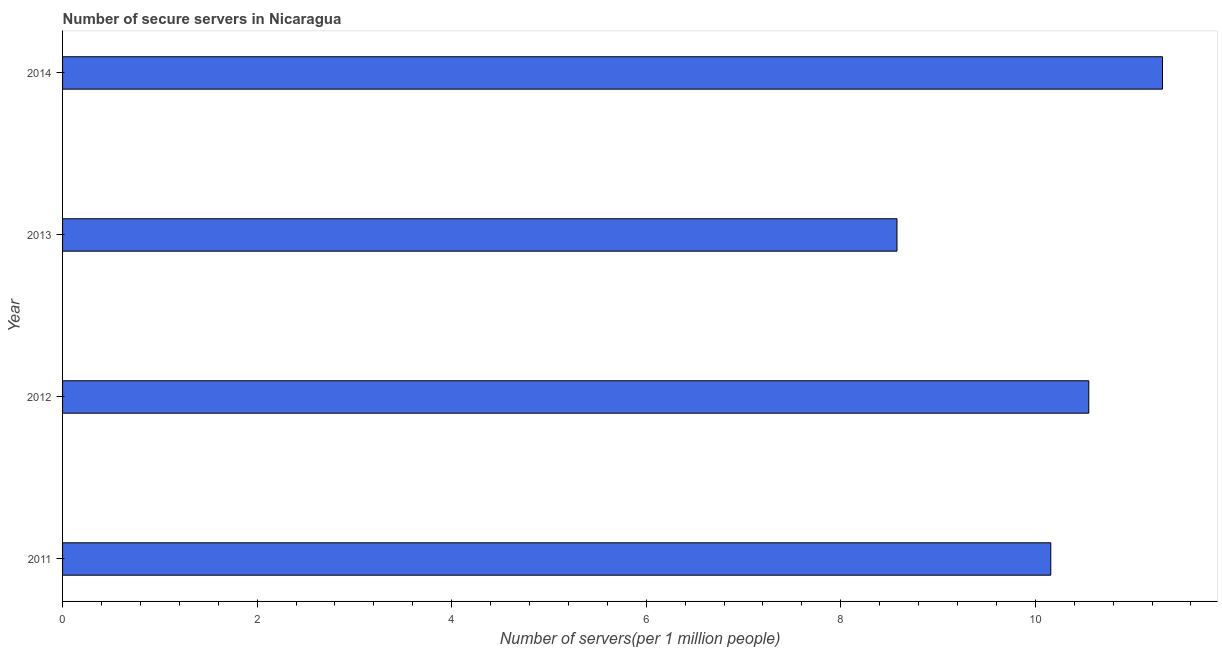Does the graph contain any zero values?
Your answer should be compact. No. What is the title of the graph?
Your response must be concise. Number of secure servers in Nicaragua. What is the label or title of the X-axis?
Your answer should be compact. Number of servers(per 1 million people). What is the label or title of the Y-axis?
Your answer should be very brief. Year. What is the number of secure internet servers in 2012?
Your response must be concise. 10.55. Across all years, what is the maximum number of secure internet servers?
Offer a very short reply. 11.31. Across all years, what is the minimum number of secure internet servers?
Ensure brevity in your answer.  8.58. What is the sum of the number of secure internet servers?
Make the answer very short. 40.59. What is the difference between the number of secure internet servers in 2011 and 2013?
Provide a short and direct response. 1.58. What is the average number of secure internet servers per year?
Your answer should be very brief. 10.15. What is the median number of secure internet servers?
Make the answer very short. 10.35. In how many years, is the number of secure internet servers greater than 8.8 ?
Keep it short and to the point. 3. Do a majority of the years between 2011 and 2012 (inclusive) have number of secure internet servers greater than 2.4 ?
Your response must be concise. Yes. Is the number of secure internet servers in 2013 less than that in 2014?
Give a very brief answer. Yes. What is the difference between the highest and the second highest number of secure internet servers?
Give a very brief answer. 0.76. Is the sum of the number of secure internet servers in 2013 and 2014 greater than the maximum number of secure internet servers across all years?
Give a very brief answer. Yes. What is the difference between the highest and the lowest number of secure internet servers?
Provide a succinct answer. 2.73. How many bars are there?
Offer a very short reply. 4. Are all the bars in the graph horizontal?
Keep it short and to the point. Yes. Are the values on the major ticks of X-axis written in scientific E-notation?
Ensure brevity in your answer.  No. What is the Number of servers(per 1 million people) of 2011?
Your answer should be compact. 10.16. What is the Number of servers(per 1 million people) of 2012?
Your answer should be very brief. 10.55. What is the Number of servers(per 1 million people) of 2013?
Offer a very short reply. 8.58. What is the Number of servers(per 1 million people) of 2014?
Keep it short and to the point. 11.31. What is the difference between the Number of servers(per 1 million people) in 2011 and 2012?
Offer a terse response. -0.39. What is the difference between the Number of servers(per 1 million people) in 2011 and 2013?
Offer a terse response. 1.58. What is the difference between the Number of servers(per 1 million people) in 2011 and 2014?
Your answer should be compact. -1.15. What is the difference between the Number of servers(per 1 million people) in 2012 and 2013?
Ensure brevity in your answer.  1.97. What is the difference between the Number of servers(per 1 million people) in 2012 and 2014?
Give a very brief answer. -0.76. What is the difference between the Number of servers(per 1 million people) in 2013 and 2014?
Offer a very short reply. -2.73. What is the ratio of the Number of servers(per 1 million people) in 2011 to that in 2012?
Offer a terse response. 0.96. What is the ratio of the Number of servers(per 1 million people) in 2011 to that in 2013?
Offer a very short reply. 1.18. What is the ratio of the Number of servers(per 1 million people) in 2011 to that in 2014?
Offer a terse response. 0.9. What is the ratio of the Number of servers(per 1 million people) in 2012 to that in 2013?
Provide a short and direct response. 1.23. What is the ratio of the Number of servers(per 1 million people) in 2012 to that in 2014?
Give a very brief answer. 0.93. What is the ratio of the Number of servers(per 1 million people) in 2013 to that in 2014?
Provide a succinct answer. 0.76. 